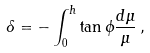<formula> <loc_0><loc_0><loc_500><loc_500>\delta = - \int _ { 0 } ^ { h } { \tan \phi { \frac { { d } \mu } { \mu } } } \, ,</formula> 